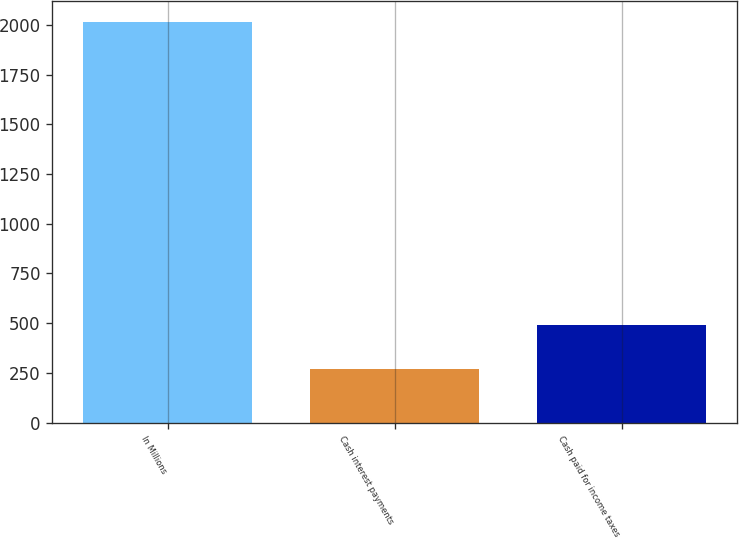<chart> <loc_0><loc_0><loc_500><loc_500><bar_chart><fcel>In Millions<fcel>Cash interest payments<fcel>Cash paid for income taxes<nl><fcel>2018<fcel>269.5<fcel>489.4<nl></chart> 